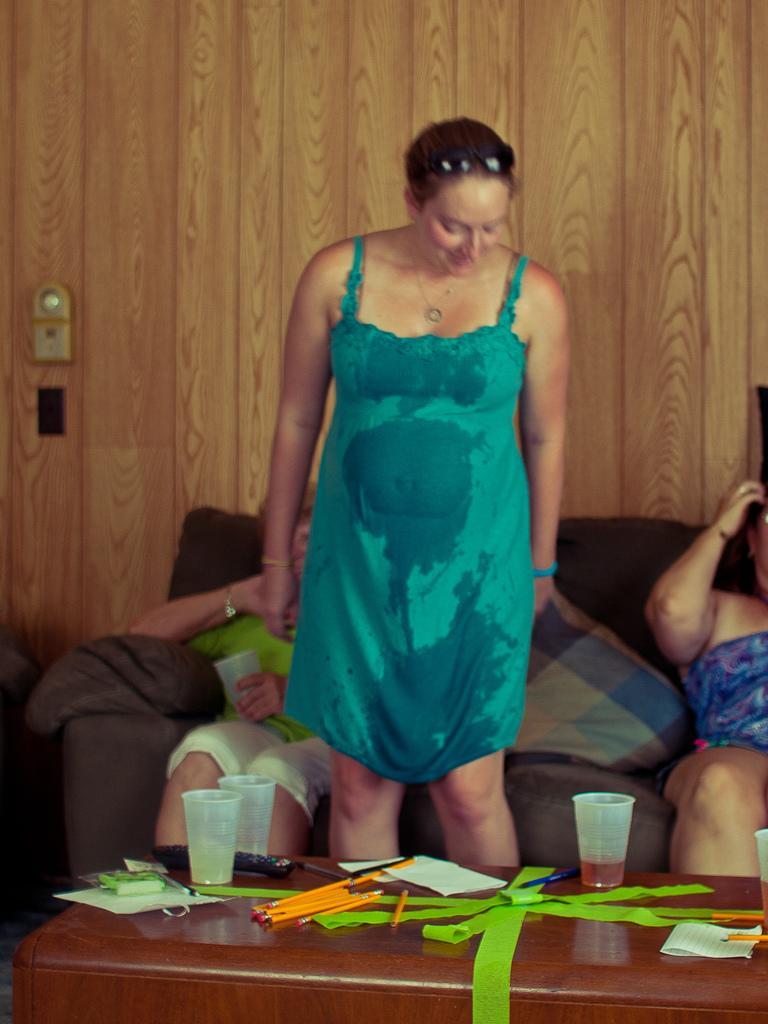Describe this image in one or two sentences. In this picture we can see woman standing and smiling an aside to them two other are sitting on sofa with pillow on it and in front on table we can see ribbons, pencils, glasses, remote and in background we can see wall. 